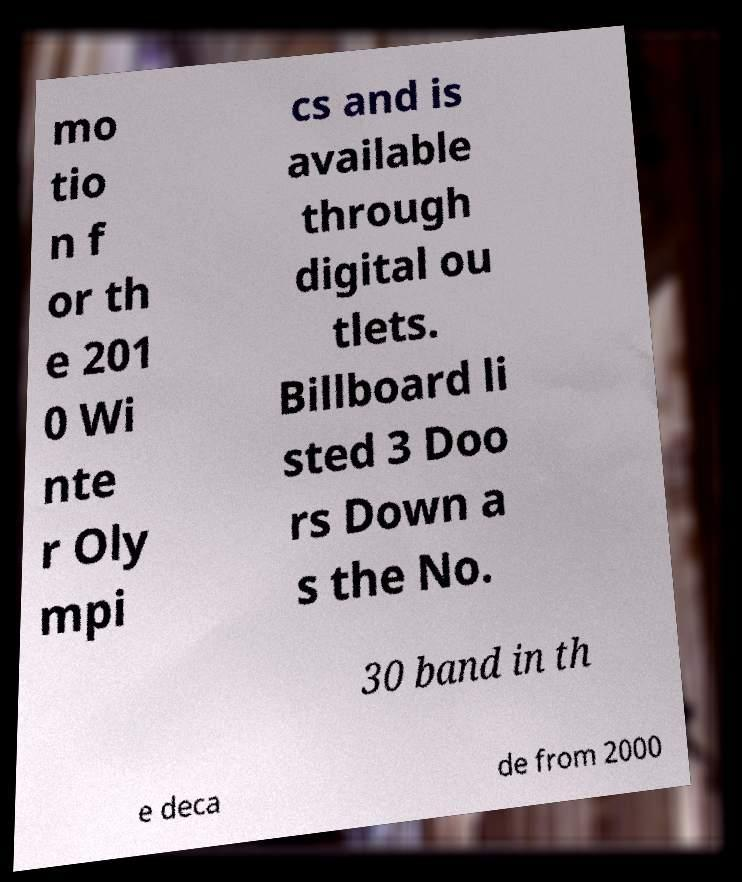Please read and relay the text visible in this image. What does it say? mo tio n f or th e 201 0 Wi nte r Oly mpi cs and is available through digital ou tlets. Billboard li sted 3 Doo rs Down a s the No. 30 band in th e deca de from 2000 